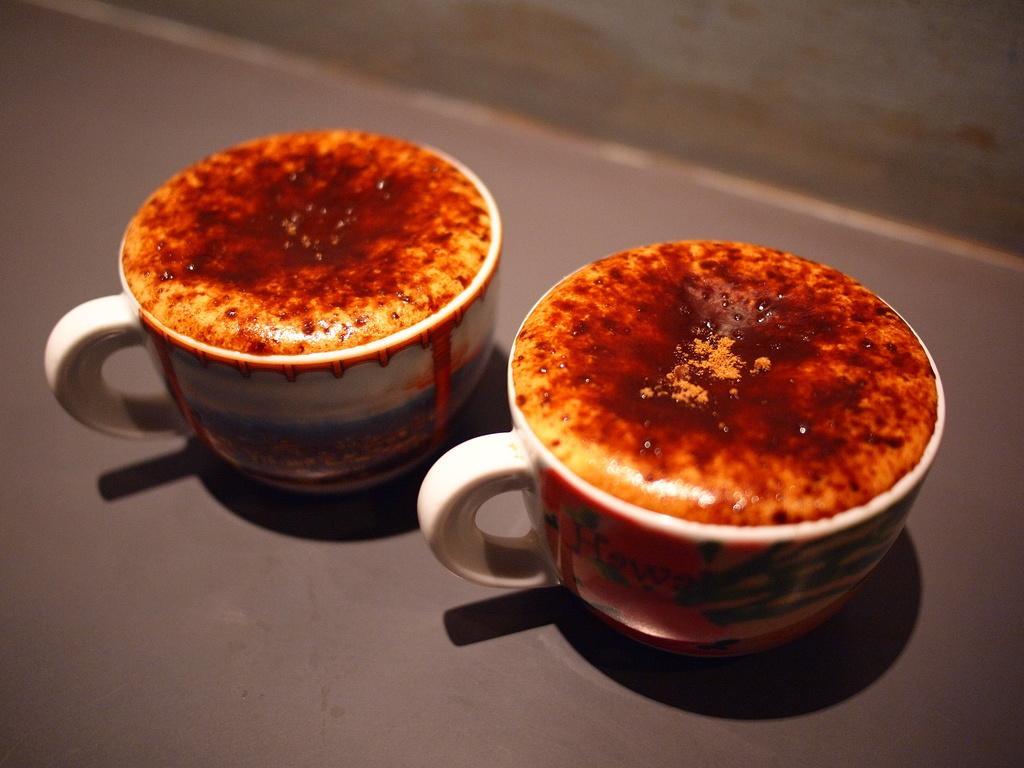How would you summarize this image in a sentence or two? In this image there are two coffee cups are kept on the floor as we can see in middle of this image. 